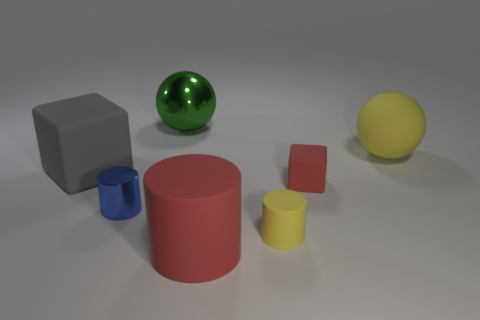Add 2 big brown shiny things. How many objects exist? 9 Subtract all cylinders. How many objects are left? 4 Subtract 0 gray balls. How many objects are left? 7 Subtract all small red blocks. Subtract all gray rubber things. How many objects are left? 5 Add 5 large rubber balls. How many large rubber balls are left? 6 Add 5 yellow matte cylinders. How many yellow matte cylinders exist? 6 